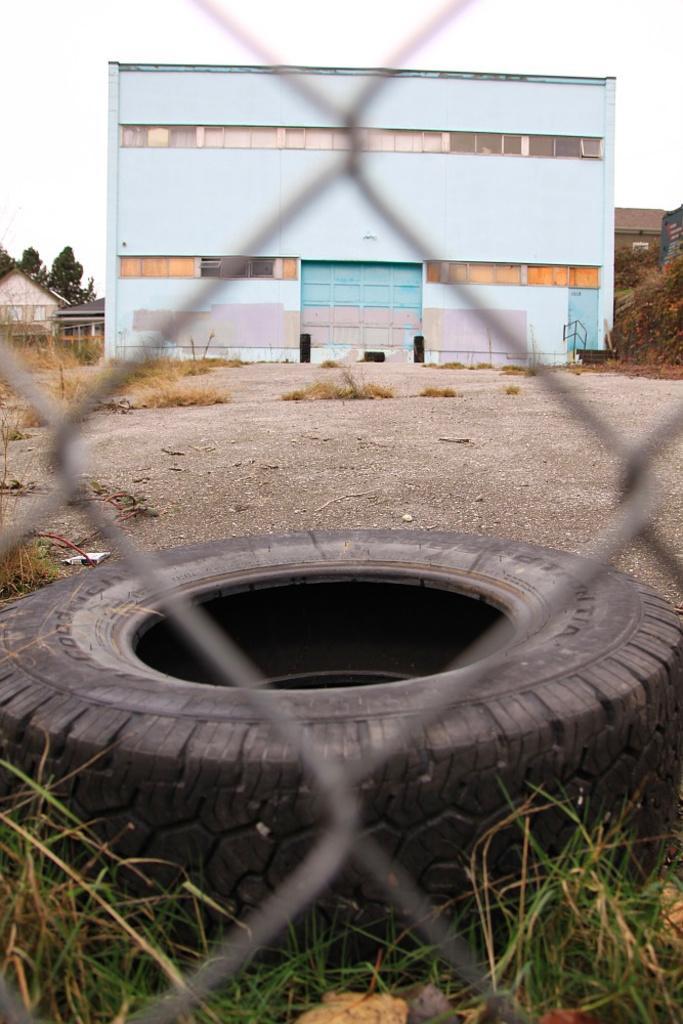How would you summarize this image in a sentence or two? In this image, we can see a tyre, grass, mesh. Background we can see buildings, houses, trees, walls, road and sky. 